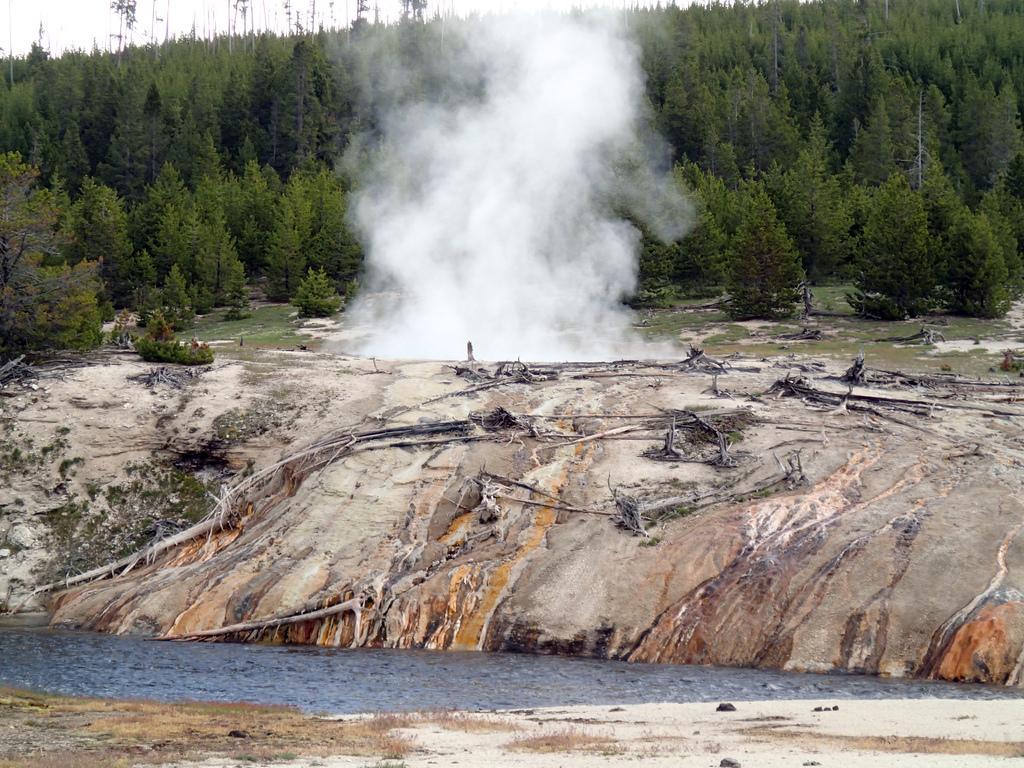In one or two sentences, can you explain what this image depicts? In the picture I can see white color smoke, trees and the water. In the background I can see the sky. 